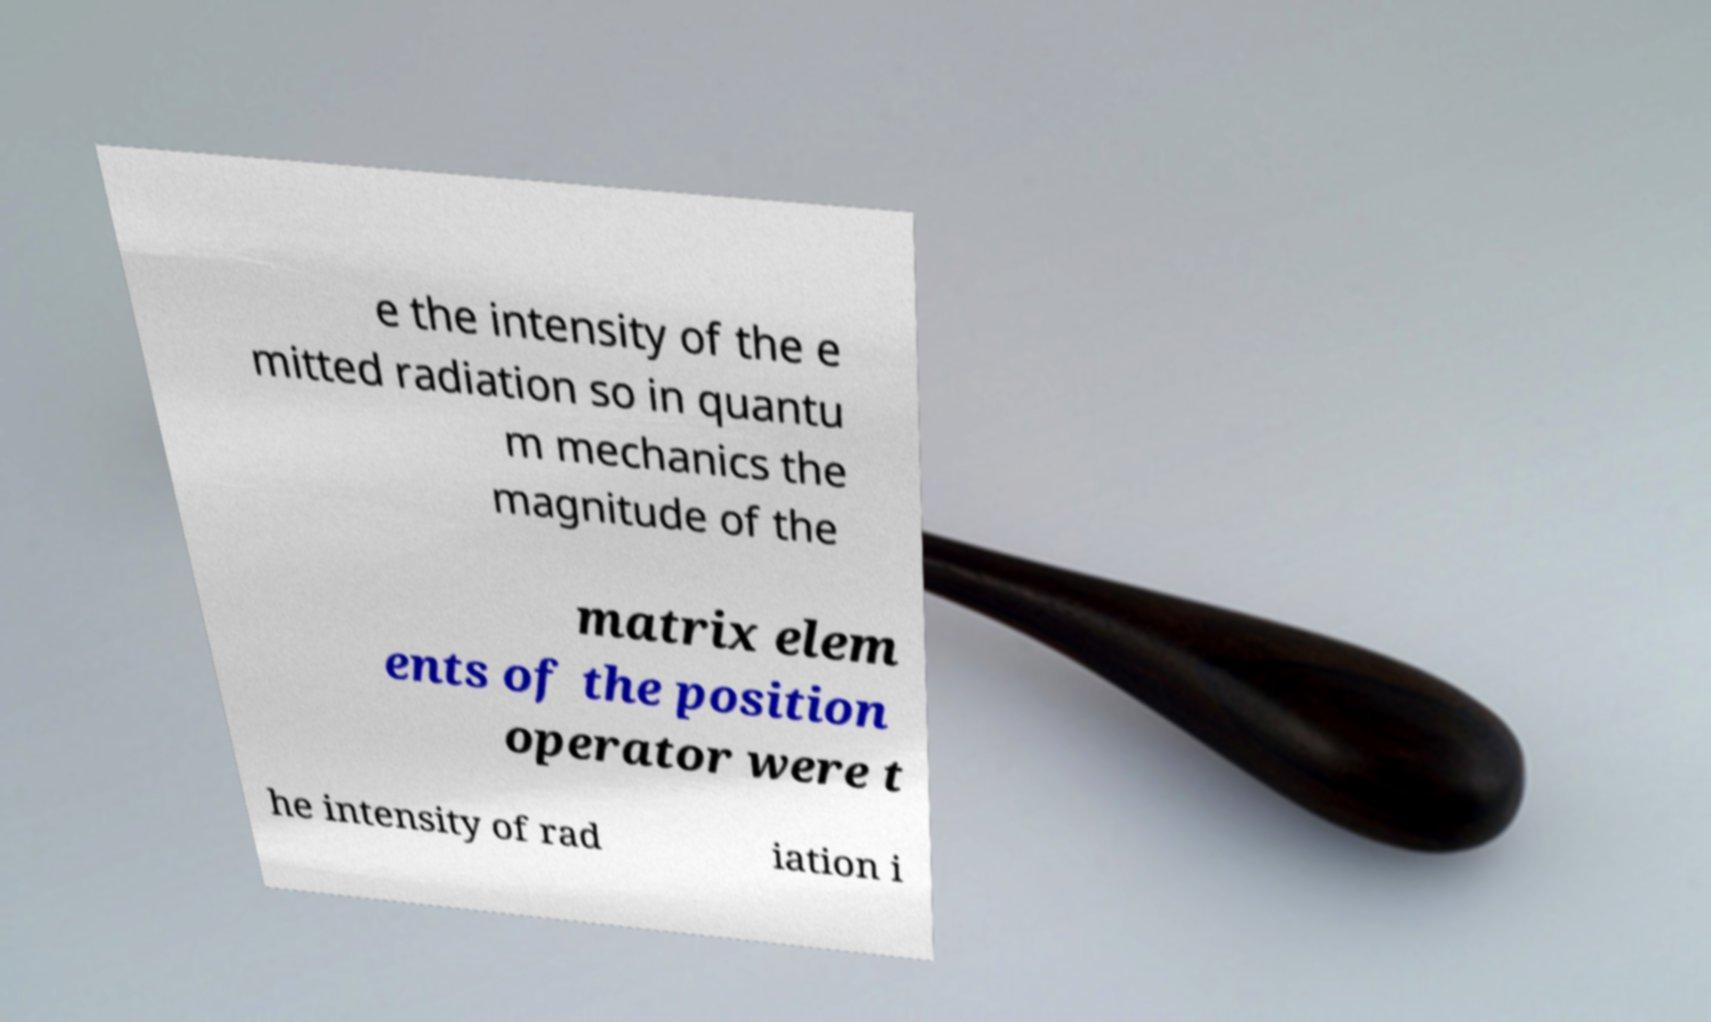Can you read and provide the text displayed in the image?This photo seems to have some interesting text. Can you extract and type it out for me? e the intensity of the e mitted radiation so in quantu m mechanics the magnitude of the matrix elem ents of the position operator were t he intensity of rad iation i 